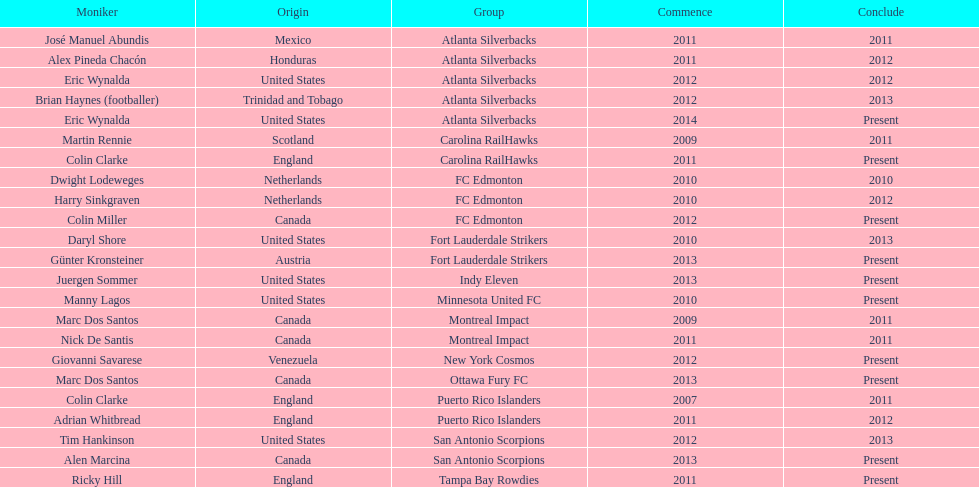What name is listed at the top? José Manuel Abundis. 